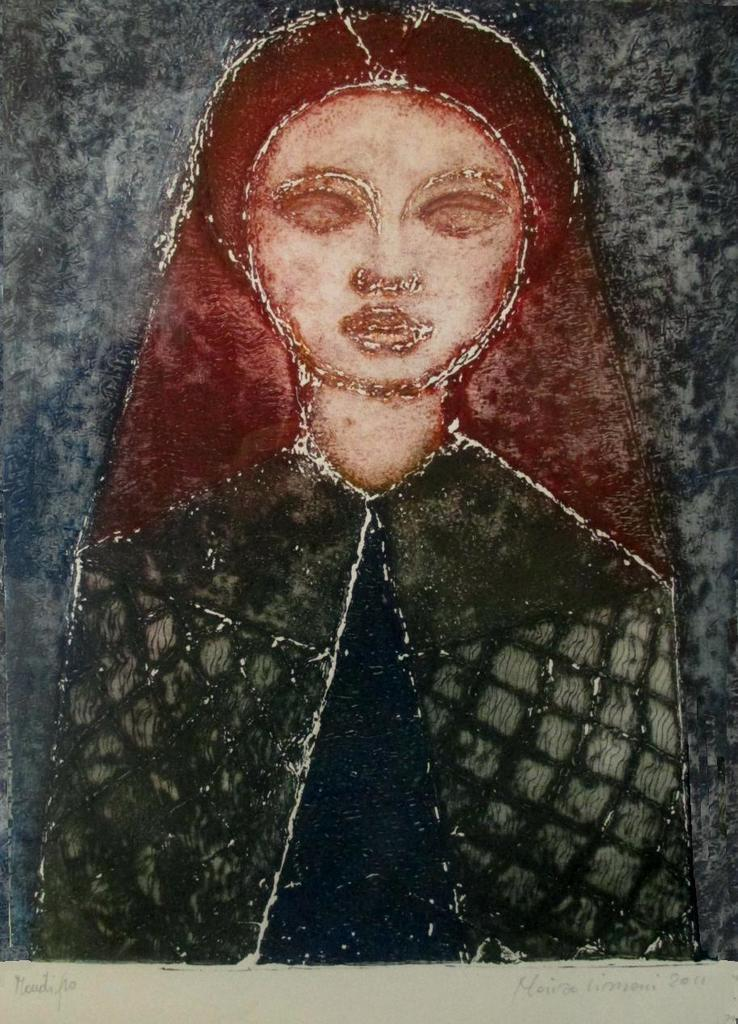What is the main subject of the painting in the image? There is a painting of a girl in the image. Is there any text associated with the painting? Yes, there is text written at the bottom of the painting. What type of destruction is depicted in the painting? There is no destruction depicted in the painting; it features a girl. Can you identify the actor who painted this image? The facts provided do not mention the artist who created the painting, so it cannot be determined from the image. 